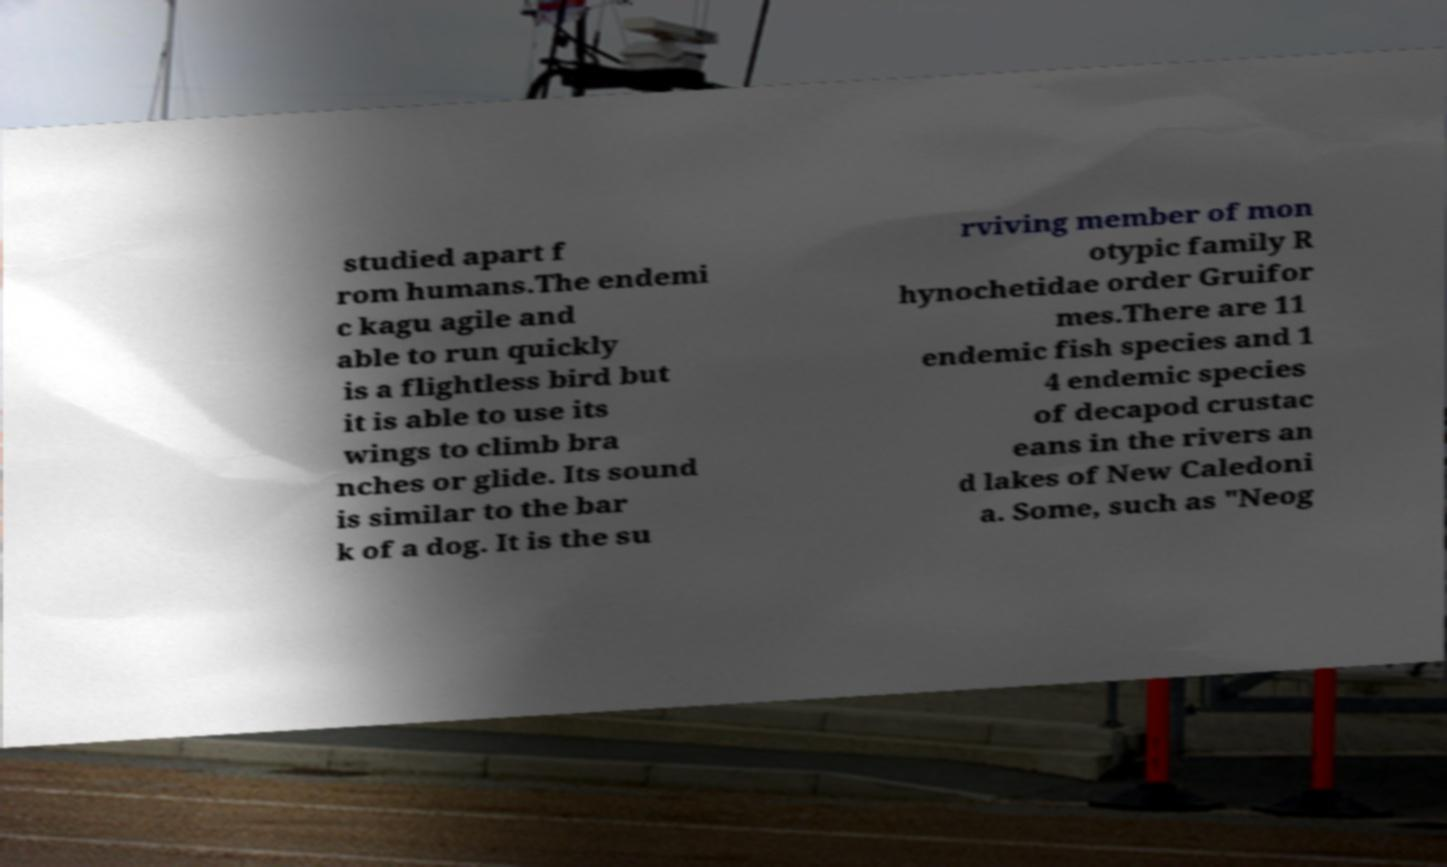Can you read and provide the text displayed in the image?This photo seems to have some interesting text. Can you extract and type it out for me? studied apart f rom humans.The endemi c kagu agile and able to run quickly is a flightless bird but it is able to use its wings to climb bra nches or glide. Its sound is similar to the bar k of a dog. It is the su rviving member of mon otypic family R hynochetidae order Gruifor mes.There are 11 endemic fish species and 1 4 endemic species of decapod crustac eans in the rivers an d lakes of New Caledoni a. Some, such as "Neog 